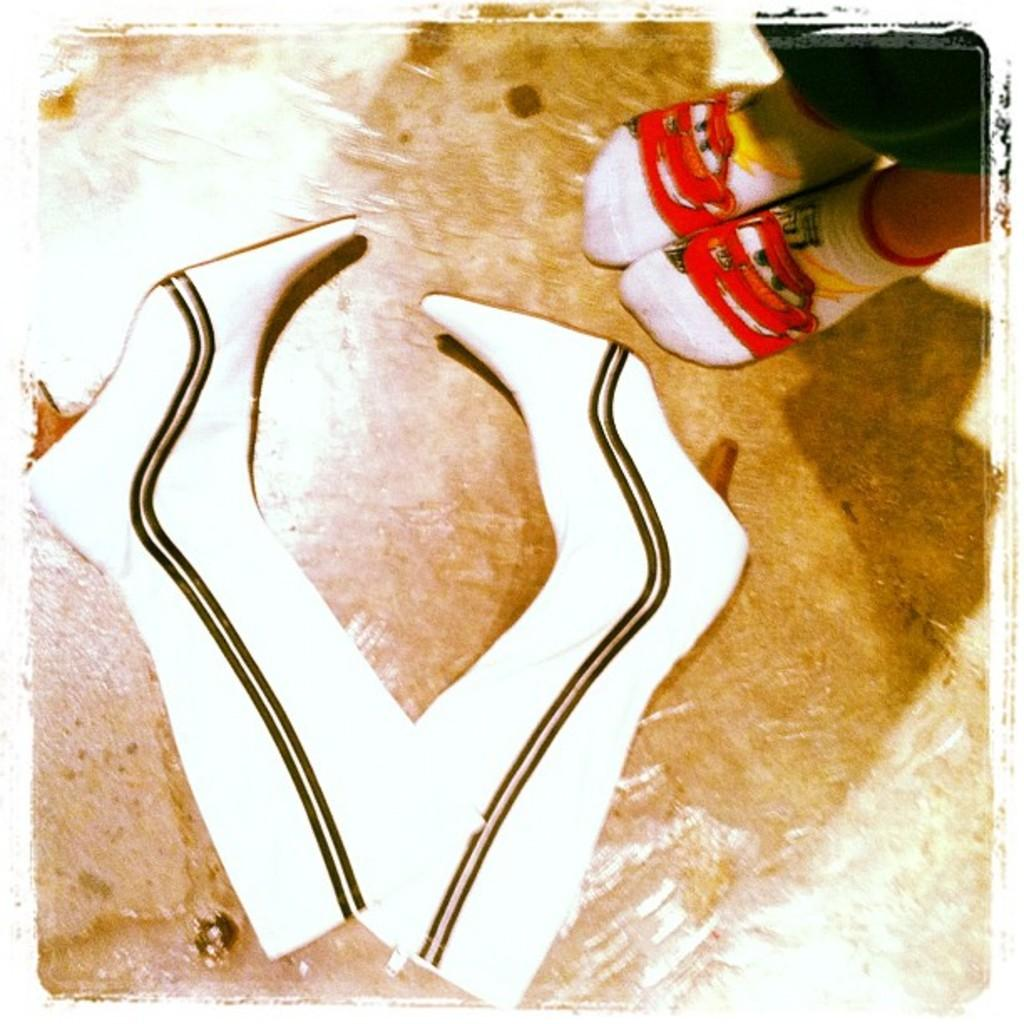What body part is visible in the image? There is a person's foot in the image. What is the foot wearing? There is a pair of shoes in the image. What is the level of friction between the person's foot and the shoes in the image? The level of friction between the person's foot and the shoes cannot be determined from the image alone. 